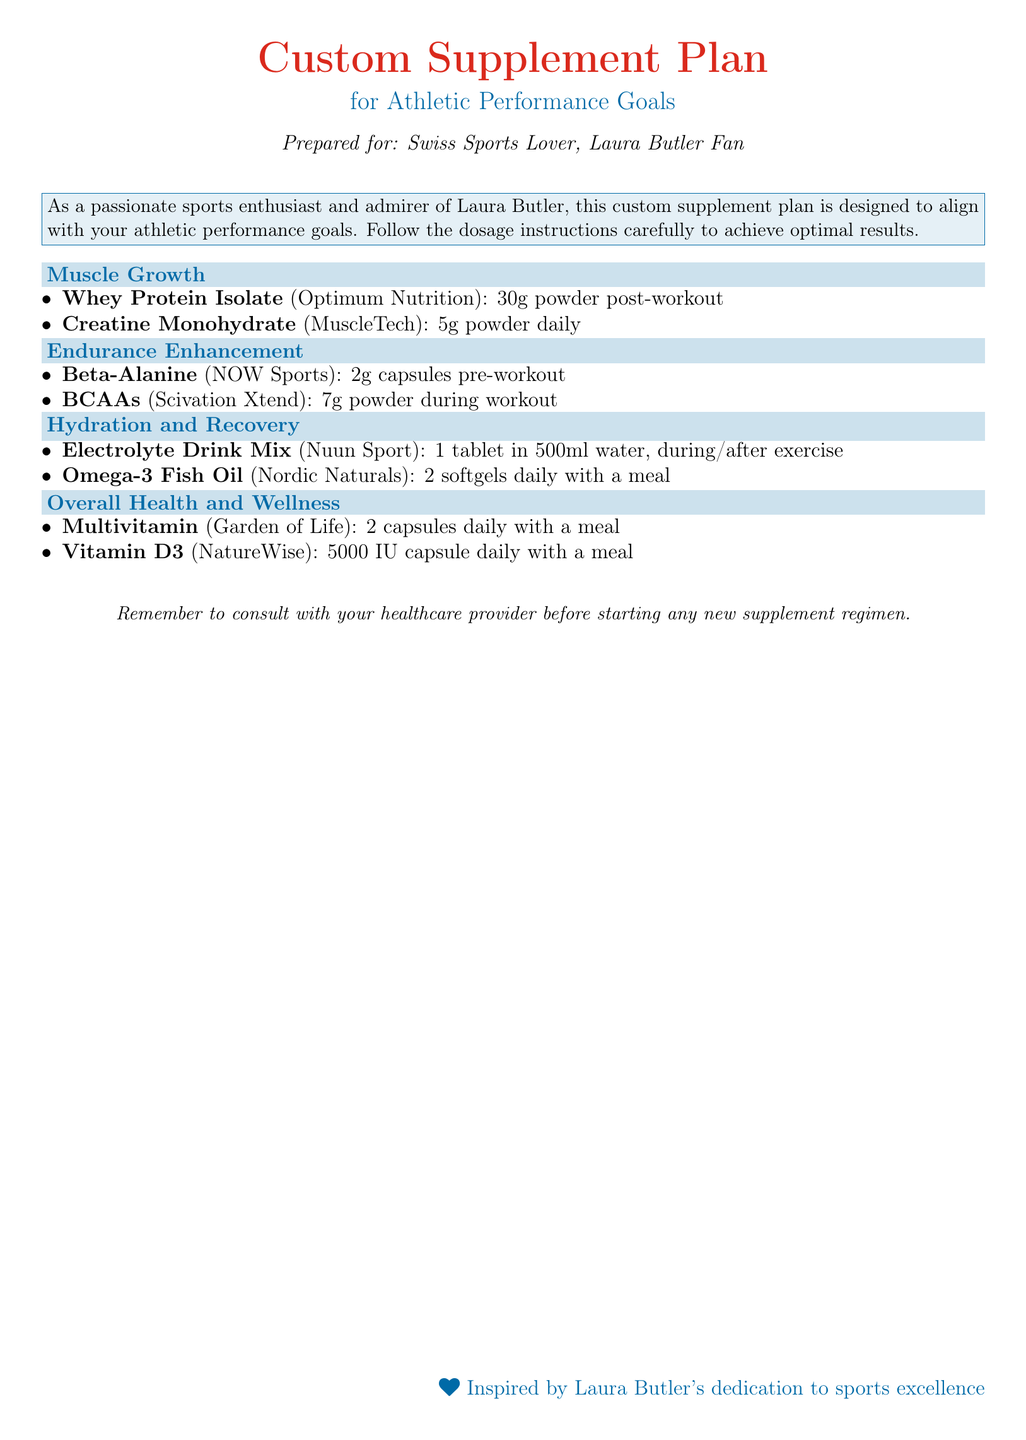What is the title of the document? The title is prominently displayed at the top of the document.
Answer: Custom Supplement Plan Who is the supplement plan prepared for? The preparation details include the recipient's identity.
Answer: Swiss Sports Lover, Laura Butler Fan What dosage of Beta-Alanine should be taken? Dosage instructions for Beta-Alanine are stated clearly in the document.
Answer: 2g capsules pre-workout How many softgels of Omega-3 Fish Oil are recommended daily? The recommendation for Omega-3 Fish Oil is specified in the section on Hydration and Recovery.
Answer: 2 softgels daily What is the daily dosage of Vitamin D3? The specific dosage for Vitamin D3 can be found under Overall Health and Wellness.
Answer: 5000 IU capsule daily Which supplement is listed under Muscle Growth? The document categorizes different supplements under performance goals, and Muscle Growth has specific items listed.
Answer: Whey Protein Isolate What is the purpose of the Electrolyte Drink Mix? The purpose can be inferred from its classification in Hydration and Recovery.
Answer: Hydration How should the Multivitamin be taken? Instructions on consumption are included in the Overall Health and Wellness section.
Answer: 2 capsules daily with a meal What is the significance of Laura Butler mentioned in the document? Laura Butler's name appears in relation to the preparation of the supplement plan and inspiration.
Answer: Inspired by dedication to sports excellence 